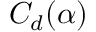Convert formula to latex. <formula><loc_0><loc_0><loc_500><loc_500>C _ { d } ( \alpha )</formula> 